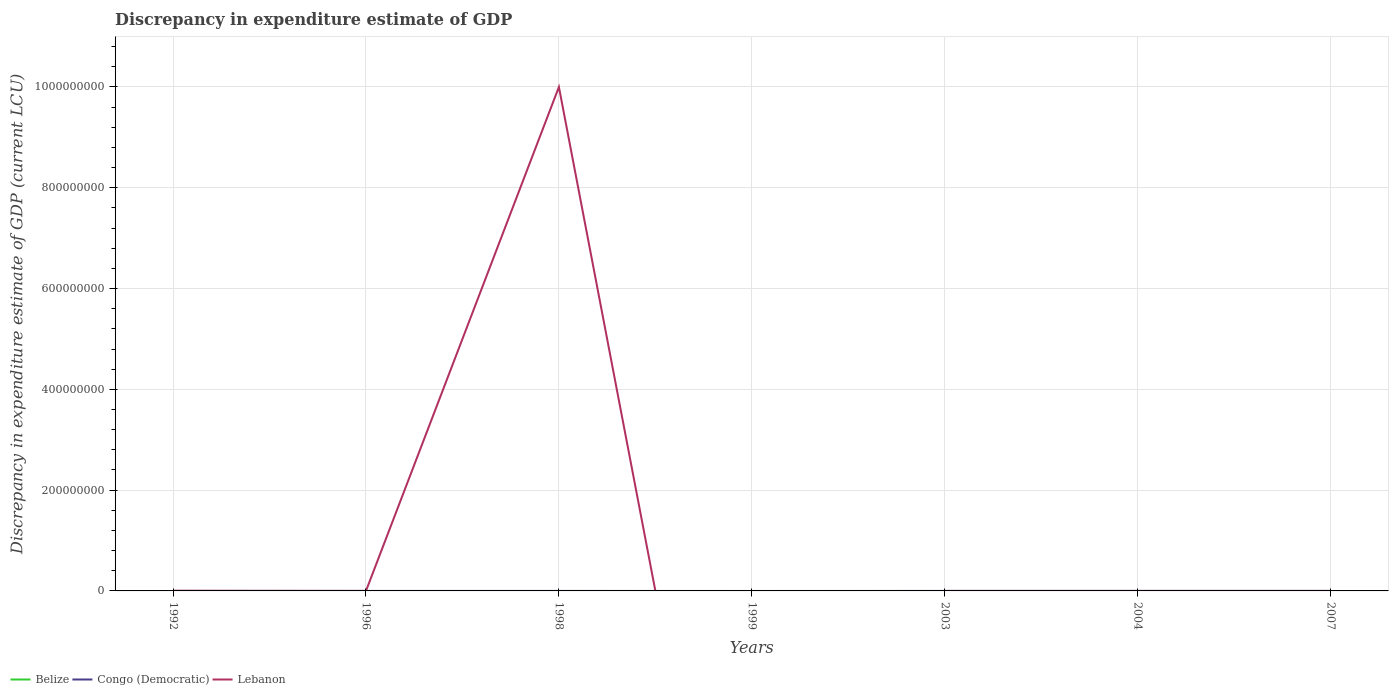How many different coloured lines are there?
Your answer should be very brief. 2. Does the line corresponding to Lebanon intersect with the line corresponding to Congo (Democratic)?
Offer a very short reply. Yes. Is the number of lines equal to the number of legend labels?
Offer a terse response. No. What is the difference between the highest and the second highest discrepancy in expenditure estimate of GDP in Lebanon?
Your response must be concise. 1.00e+09. How many lines are there?
Ensure brevity in your answer.  2. How many years are there in the graph?
Provide a short and direct response. 7. What is the difference between two consecutive major ticks on the Y-axis?
Provide a short and direct response. 2.00e+08. Are the values on the major ticks of Y-axis written in scientific E-notation?
Your answer should be very brief. No. Does the graph contain grids?
Give a very brief answer. Yes. Where does the legend appear in the graph?
Make the answer very short. Bottom left. How many legend labels are there?
Provide a succinct answer. 3. How are the legend labels stacked?
Offer a terse response. Horizontal. What is the title of the graph?
Ensure brevity in your answer.  Discrepancy in expenditure estimate of GDP. Does "Dominican Republic" appear as one of the legend labels in the graph?
Offer a very short reply. No. What is the label or title of the X-axis?
Your answer should be compact. Years. What is the label or title of the Y-axis?
Offer a terse response. Discrepancy in expenditure estimate of GDP (current LCU). What is the Discrepancy in expenditure estimate of GDP (current LCU) of Belize in 1992?
Provide a succinct answer. 0. What is the Discrepancy in expenditure estimate of GDP (current LCU) of Congo (Democratic) in 1992?
Offer a very short reply. 200. What is the Discrepancy in expenditure estimate of GDP (current LCU) of Lebanon in 1992?
Provide a short and direct response. 3.28e+05. What is the Discrepancy in expenditure estimate of GDP (current LCU) in Belize in 1996?
Keep it short and to the point. 0. What is the Discrepancy in expenditure estimate of GDP (current LCU) of Congo (Democratic) in 1998?
Your answer should be very brief. 0. What is the Discrepancy in expenditure estimate of GDP (current LCU) in Lebanon in 1998?
Give a very brief answer. 1.00e+09. What is the Discrepancy in expenditure estimate of GDP (current LCU) of Belize in 1999?
Your answer should be very brief. 0. What is the Discrepancy in expenditure estimate of GDP (current LCU) in Congo (Democratic) in 1999?
Keep it short and to the point. 0. What is the Discrepancy in expenditure estimate of GDP (current LCU) in Congo (Democratic) in 2003?
Your answer should be very brief. 6e-5. What is the Discrepancy in expenditure estimate of GDP (current LCU) of Lebanon in 2003?
Make the answer very short. 0. What is the Discrepancy in expenditure estimate of GDP (current LCU) in Belize in 2004?
Ensure brevity in your answer.  0. What is the Discrepancy in expenditure estimate of GDP (current LCU) of Congo (Democratic) in 2007?
Keep it short and to the point. 10. Across all years, what is the maximum Discrepancy in expenditure estimate of GDP (current LCU) of Lebanon?
Your answer should be very brief. 1.00e+09. Across all years, what is the minimum Discrepancy in expenditure estimate of GDP (current LCU) of Congo (Democratic)?
Provide a succinct answer. 0. Across all years, what is the minimum Discrepancy in expenditure estimate of GDP (current LCU) in Lebanon?
Give a very brief answer. 0. What is the total Discrepancy in expenditure estimate of GDP (current LCU) of Congo (Democratic) in the graph?
Make the answer very short. 210. What is the total Discrepancy in expenditure estimate of GDP (current LCU) in Lebanon in the graph?
Keep it short and to the point. 1.00e+09. What is the difference between the Discrepancy in expenditure estimate of GDP (current LCU) in Lebanon in 1992 and that in 1998?
Give a very brief answer. -1.00e+09. What is the difference between the Discrepancy in expenditure estimate of GDP (current LCU) in Congo (Democratic) in 1992 and that in 2003?
Provide a short and direct response. 200. What is the difference between the Discrepancy in expenditure estimate of GDP (current LCU) in Lebanon in 1992 and that in 2003?
Your response must be concise. 3.28e+05. What is the difference between the Discrepancy in expenditure estimate of GDP (current LCU) of Congo (Democratic) in 1992 and that in 2007?
Offer a very short reply. 190. What is the difference between the Discrepancy in expenditure estimate of GDP (current LCU) in Lebanon in 1998 and that in 2003?
Offer a very short reply. 1.00e+09. What is the difference between the Discrepancy in expenditure estimate of GDP (current LCU) of Congo (Democratic) in 2003 and that in 2007?
Offer a very short reply. -10. What is the difference between the Discrepancy in expenditure estimate of GDP (current LCU) of Congo (Democratic) in 1992 and the Discrepancy in expenditure estimate of GDP (current LCU) of Lebanon in 1998?
Your answer should be compact. -1.00e+09. What is the difference between the Discrepancy in expenditure estimate of GDP (current LCU) in Congo (Democratic) in 1992 and the Discrepancy in expenditure estimate of GDP (current LCU) in Lebanon in 2003?
Your answer should be compact. 200. What is the average Discrepancy in expenditure estimate of GDP (current LCU) in Congo (Democratic) per year?
Your answer should be compact. 30. What is the average Discrepancy in expenditure estimate of GDP (current LCU) in Lebanon per year?
Make the answer very short. 1.43e+08. In the year 1992, what is the difference between the Discrepancy in expenditure estimate of GDP (current LCU) of Congo (Democratic) and Discrepancy in expenditure estimate of GDP (current LCU) of Lebanon?
Provide a succinct answer. -3.28e+05. In the year 2003, what is the difference between the Discrepancy in expenditure estimate of GDP (current LCU) of Congo (Democratic) and Discrepancy in expenditure estimate of GDP (current LCU) of Lebanon?
Provide a short and direct response. -0. What is the ratio of the Discrepancy in expenditure estimate of GDP (current LCU) in Lebanon in 1992 to that in 1998?
Ensure brevity in your answer.  0. What is the ratio of the Discrepancy in expenditure estimate of GDP (current LCU) of Congo (Democratic) in 1992 to that in 2003?
Keep it short and to the point. 3.33e+06. What is the ratio of the Discrepancy in expenditure estimate of GDP (current LCU) of Lebanon in 1992 to that in 2003?
Make the answer very short. 3.28e+08. What is the ratio of the Discrepancy in expenditure estimate of GDP (current LCU) in Congo (Democratic) in 1992 to that in 2007?
Keep it short and to the point. 20. What is the ratio of the Discrepancy in expenditure estimate of GDP (current LCU) in Lebanon in 1998 to that in 2003?
Offer a terse response. 1.00e+12. What is the difference between the highest and the second highest Discrepancy in expenditure estimate of GDP (current LCU) in Congo (Democratic)?
Make the answer very short. 190. What is the difference between the highest and the second highest Discrepancy in expenditure estimate of GDP (current LCU) of Lebanon?
Your response must be concise. 1.00e+09. What is the difference between the highest and the lowest Discrepancy in expenditure estimate of GDP (current LCU) in Lebanon?
Keep it short and to the point. 1.00e+09. 